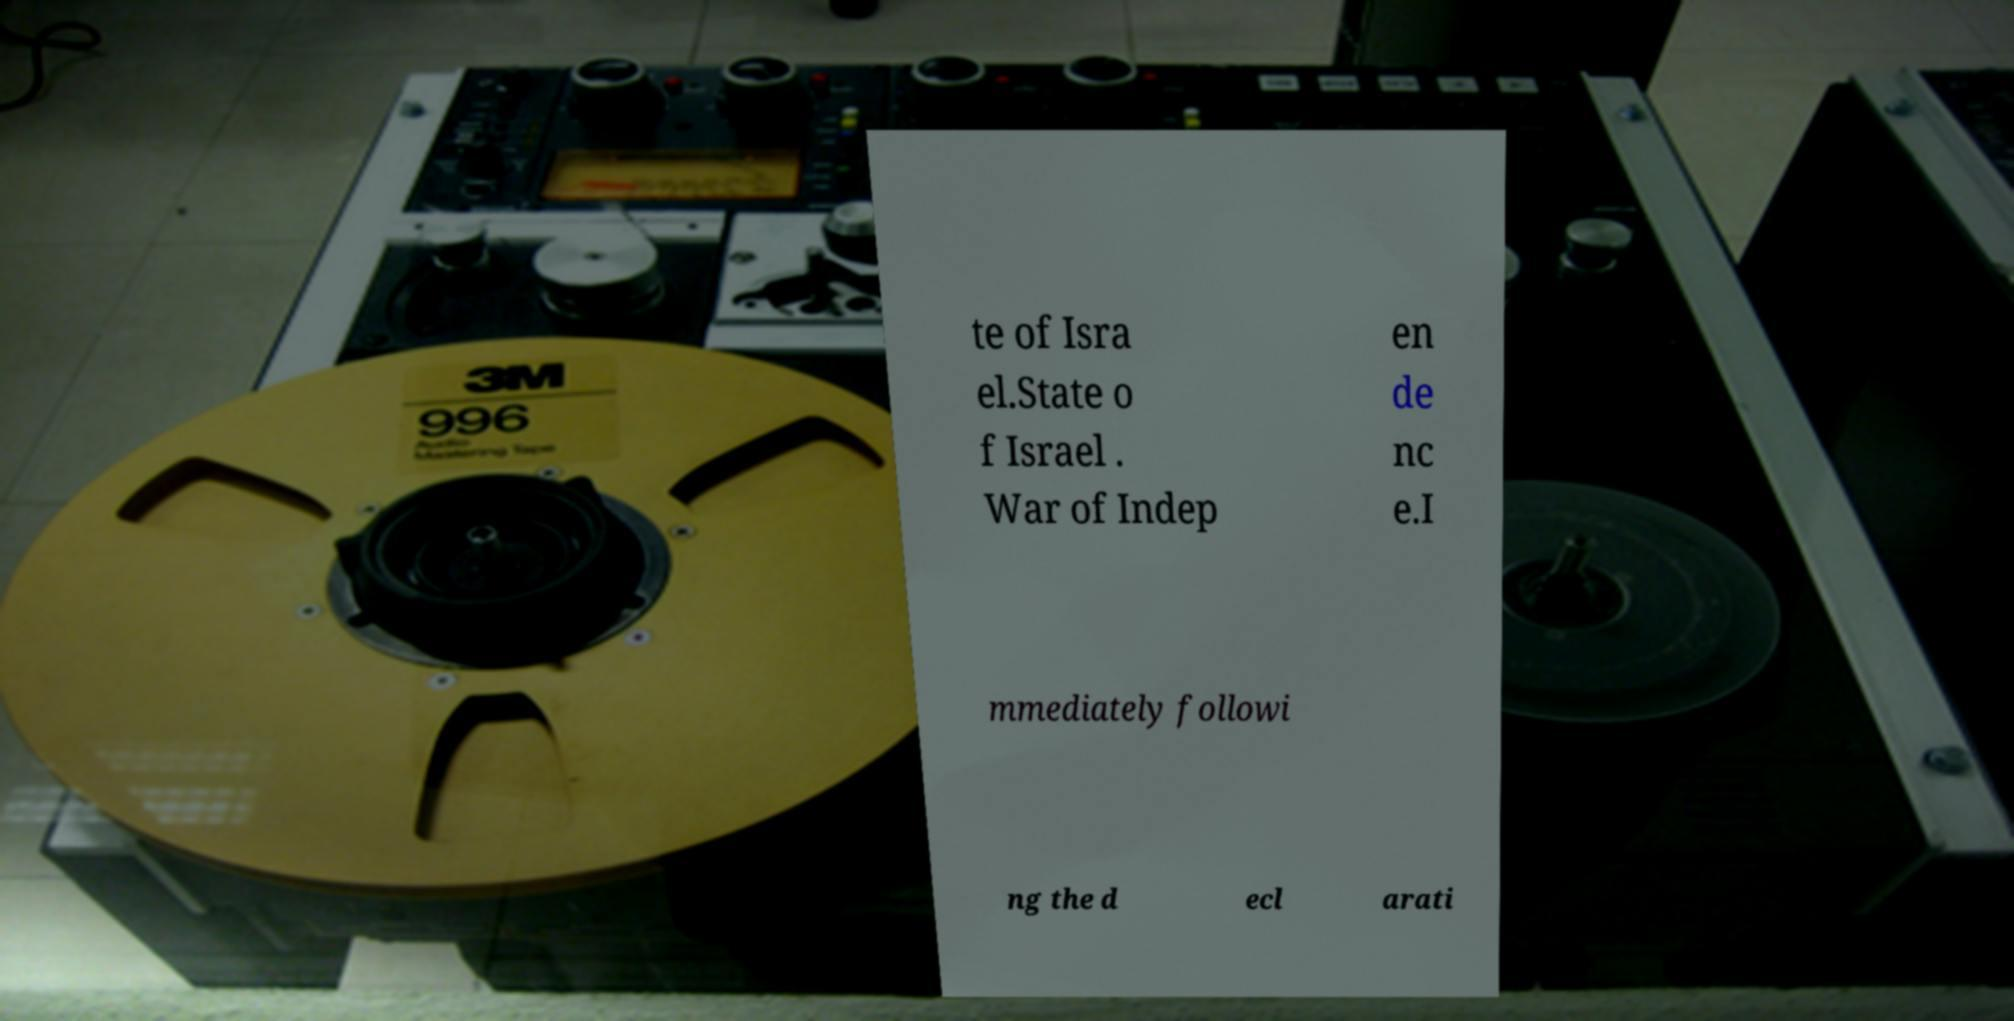Could you assist in decoding the text presented in this image and type it out clearly? te of Isra el.State o f Israel . War of Indep en de nc e.I mmediately followi ng the d ecl arati 